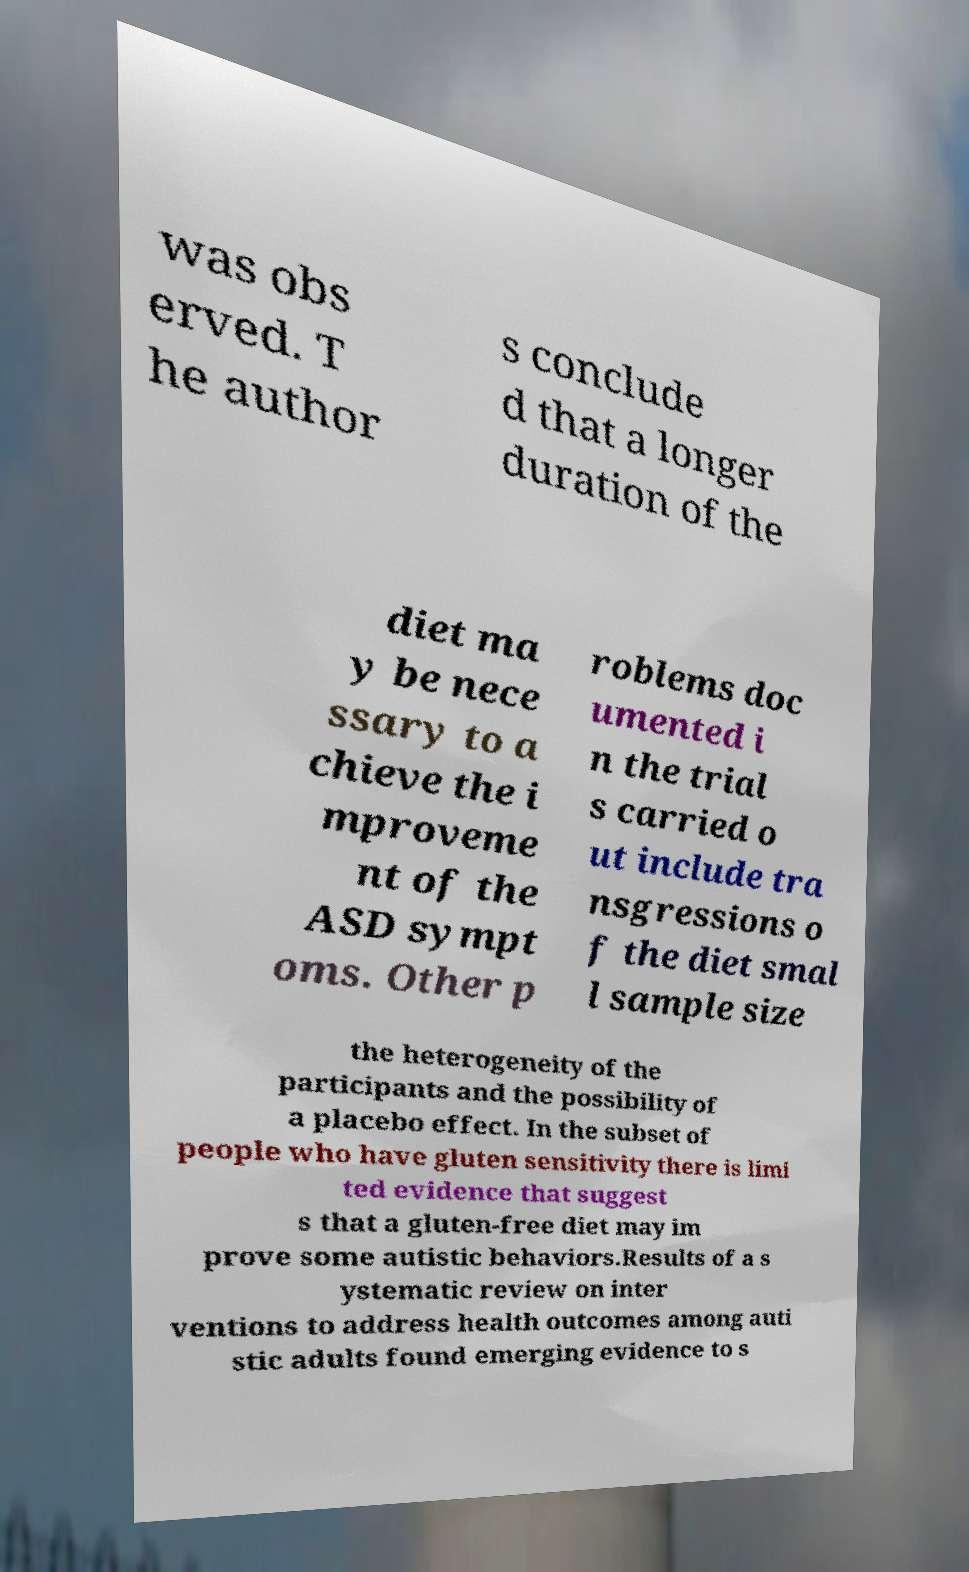Can you read and provide the text displayed in the image?This photo seems to have some interesting text. Can you extract and type it out for me? was obs erved. T he author s conclude d that a longer duration of the diet ma y be nece ssary to a chieve the i mproveme nt of the ASD sympt oms. Other p roblems doc umented i n the trial s carried o ut include tra nsgressions o f the diet smal l sample size the heterogeneity of the participants and the possibility of a placebo effect. In the subset of people who have gluten sensitivity there is limi ted evidence that suggest s that a gluten-free diet may im prove some autistic behaviors.Results of a s ystematic review on inter ventions to address health outcomes among auti stic adults found emerging evidence to s 